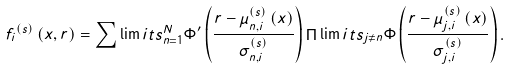Convert formula to latex. <formula><loc_0><loc_0><loc_500><loc_500>f _ { i } & ^ { \left ( s \right ) } \left ( x , r \right ) = \sum \lim i t s _ { n = 1 } ^ { N } { \Phi ^ { \prime } \left ( { \frac { { r - \mu _ { n , i } ^ { \left ( s \right ) } \left ( x \right ) } } { \sigma _ { n , i } ^ { \left ( s \right ) } } } \right ) } \mathop \Pi \lim i t s _ { j \ne n } \Phi \left ( { \frac { { r - \mu _ { j , i } ^ { \left ( s \right ) } \left ( x \right ) } } { \sigma _ { j , i } ^ { \left ( s \right ) } } } \right ) .</formula> 